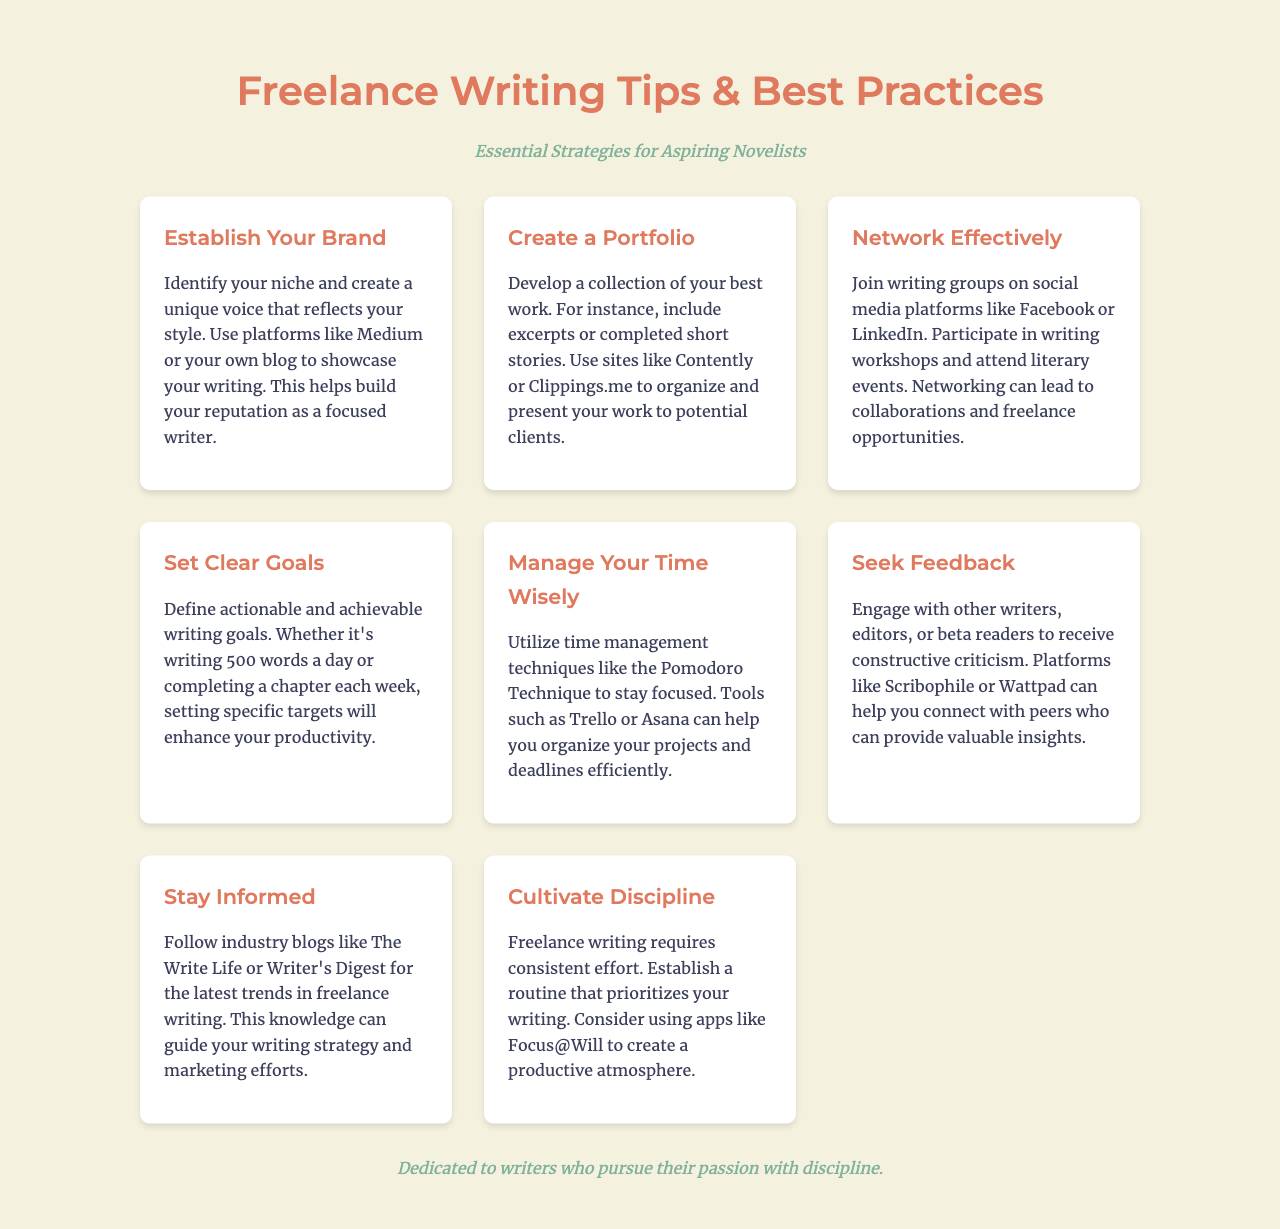What is the title of the brochure? The title is mentioned prominently at the top of the document.
Answer: Freelance Writing Tips & Best Practices What is the subtitle of the brochure? The subtitle is located directly under the title and provides context for the information presented.
Answer: Essential Strategies for Aspiring Novelists How many sections are in the document? The document lists eight different sections that cover various tips and best practices.
Answer: 8 What technique is suggested for managing time wisely? The document includes a specific technique in the section about time management that helps improve focus.
Answer: Pomodoro Technique What is one platform mentioned for creating a portfolio? The document provides examples of platforms where writers can organize and showcase their work.
Answer: Clippings.me Which industry blogs are recommended for staying informed? The document specifies certain blogs that provide insights and trends in freelance writing.
Answer: The Write Life, Writer's Digest What is emphasized as a key trait for freelance writers? The document stresses the importance of a particular quality that writers should cultivate.
Answer: Discipline Which tools are suggested for project organization? The document mentions tools in the time management section that can help writers keep their projects on track.
Answer: Trello, Asana 